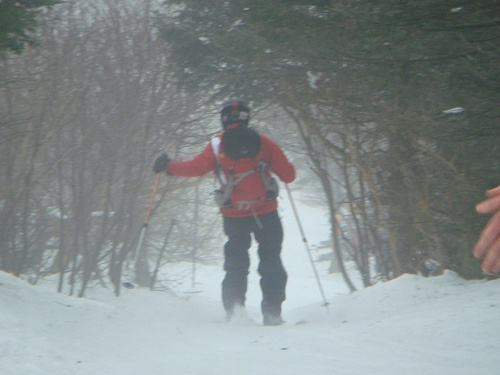Describe the objects in this image and their specific colors. I can see people in gray, brown, darkgray, and lightgray tones, backpack in gray and brown tones, people in gray and salmon tones, and skis in gray, lightgray, and darkgray tones in this image. 